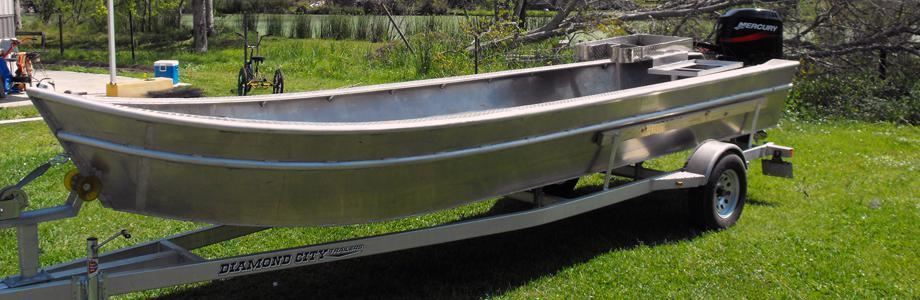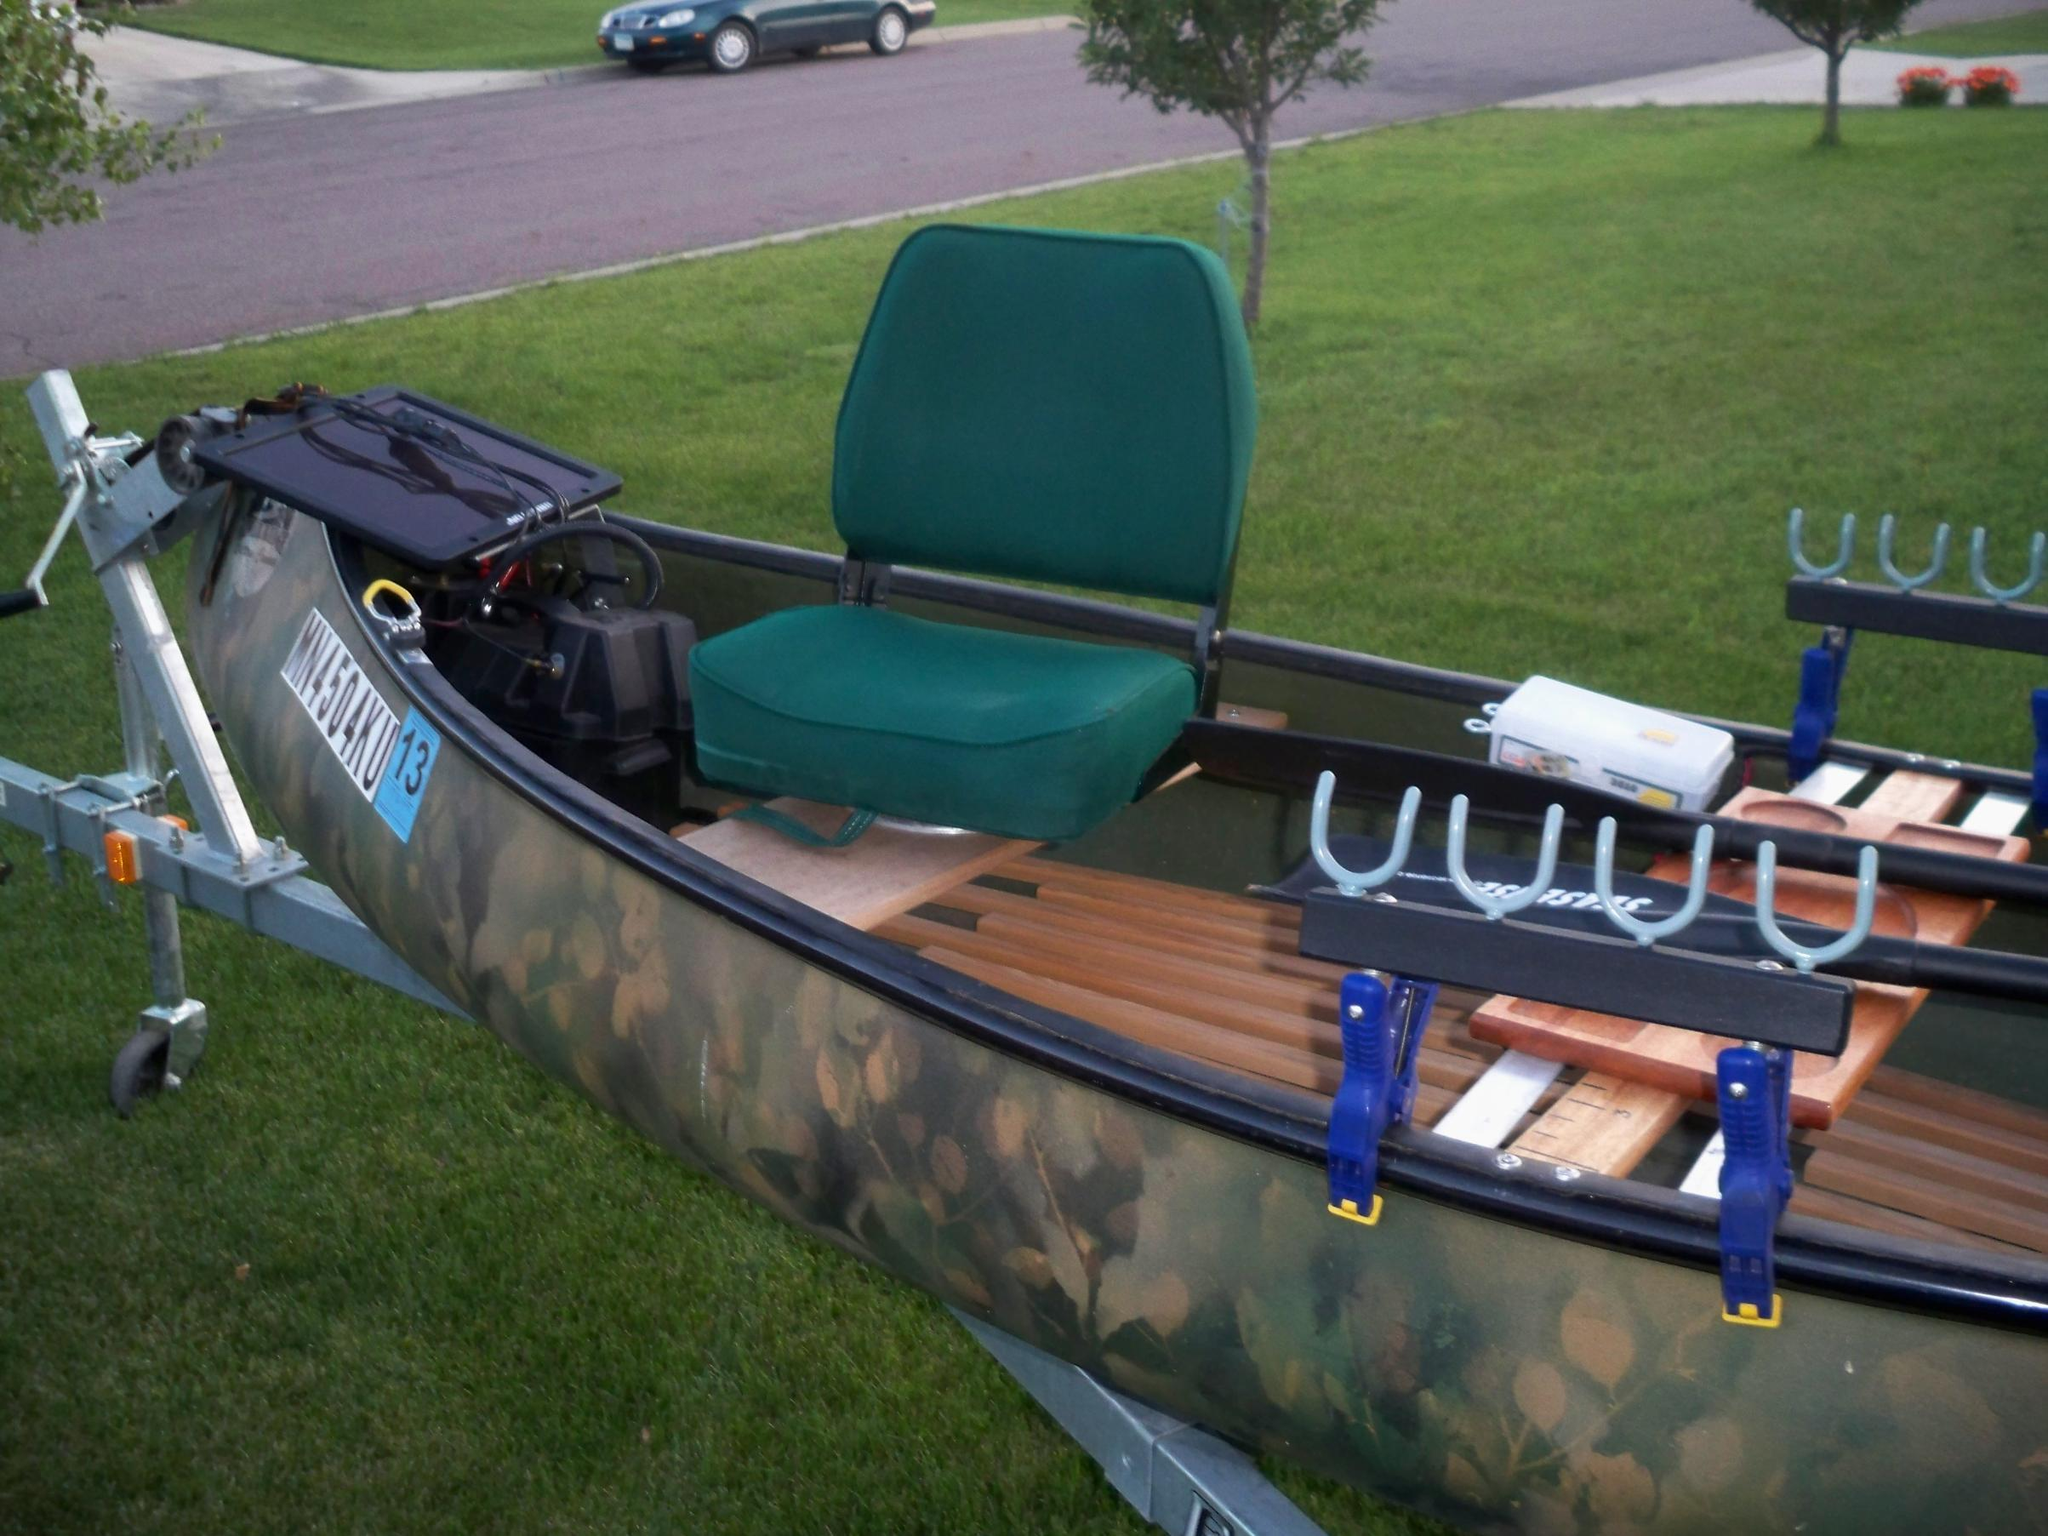The first image is the image on the left, the second image is the image on the right. For the images shown, is this caption "At least one of the boats is not near water." true? Answer yes or no. Yes. The first image is the image on the left, the second image is the image on the right. For the images shown, is this caption "At least one boat is not touching water." true? Answer yes or no. Yes. 